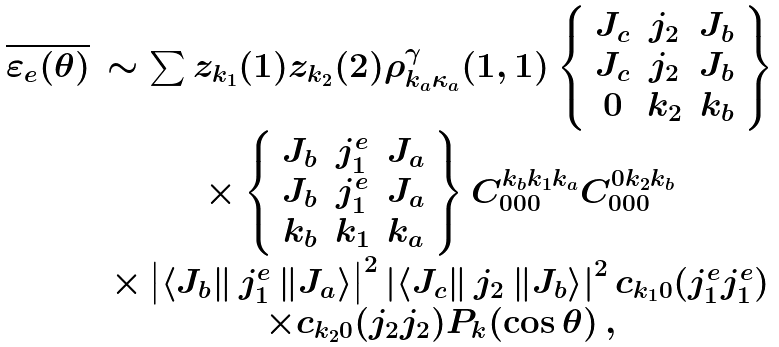Convert formula to latex. <formula><loc_0><loc_0><loc_500><loc_500>\begin{array} { c c } \overline { \varepsilon _ { e } ( \theta ) } & \sim \sum z _ { k _ { 1 } } ( 1 ) z _ { k _ { 2 } } ( 2 ) \rho _ { k _ { a } \kappa _ { a } } ^ { \gamma } ( 1 , 1 ) \left \{ \begin{array} { c c c } J _ { c } & j _ { 2 } & J _ { b } \\ J _ { c } & j _ { 2 } & J _ { b } \\ 0 & k _ { 2 } & k _ { b } \end{array} \right \} \\ & \times \left \{ \begin{array} { c c c } J _ { b } & j ^ { e } _ { 1 } & J _ { a } \\ J _ { b } & j ^ { e } _ { 1 } & J _ { a } \\ k _ { b } & k _ { 1 } & k _ { a } \end{array} \right \} C _ { 0 0 0 } ^ { k _ { b } k _ { 1 } k _ { a } } C _ { 0 0 0 } ^ { 0 k _ { 2 } k _ { b } } \\ & \times \left | \left \langle J _ { b } \right \| j ^ { e } _ { 1 } \left \| J _ { a } \right \rangle \right | ^ { 2 } \left | \left \langle J _ { c } \right \| j _ { 2 } \left \| J _ { b } \right \rangle \right | ^ { 2 } c _ { k _ { 1 } 0 } ( j ^ { e } _ { 1 } j ^ { e } _ { 1 } ) \\ & \times c _ { k _ { 2 } 0 } ( j _ { 2 } j _ { 2 } ) P _ { k } ( \cos \theta ) \, , \end{array}</formula> 